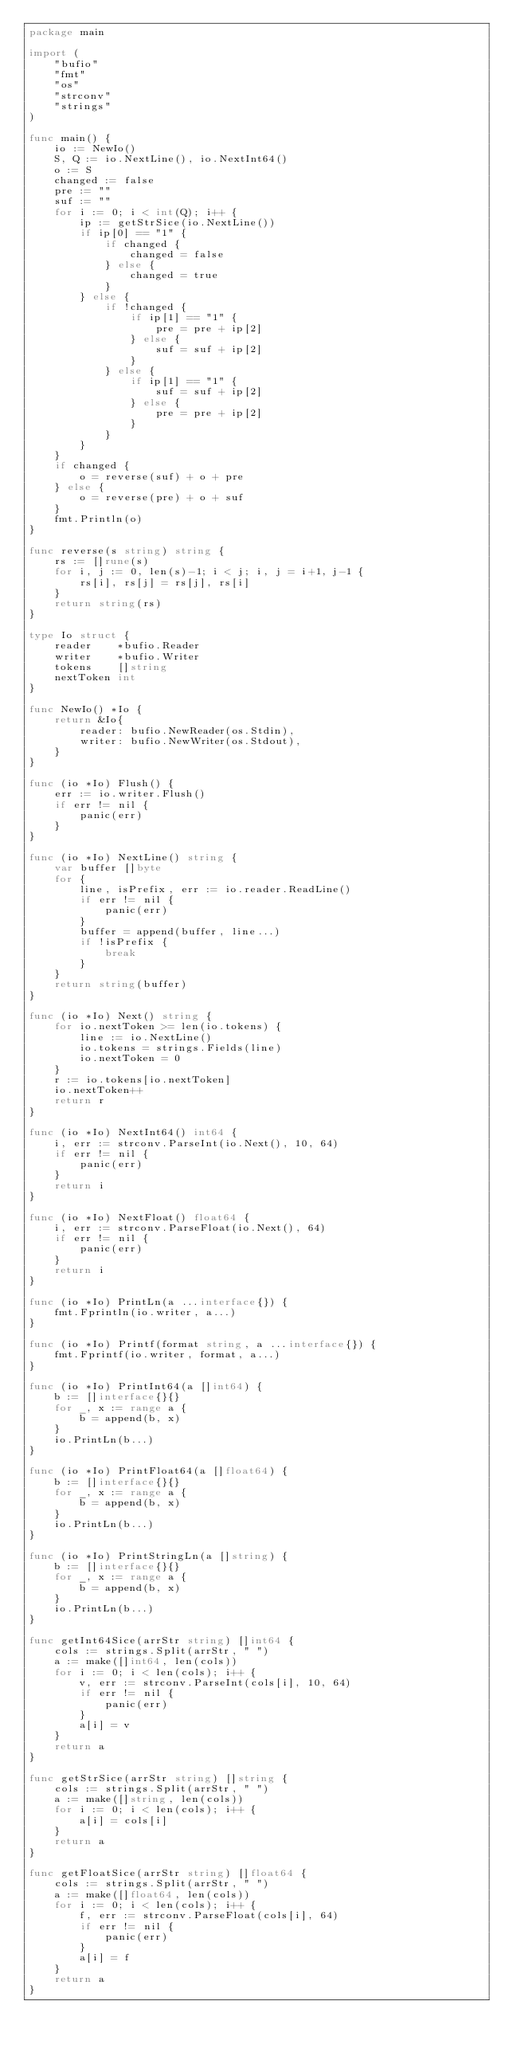Convert code to text. <code><loc_0><loc_0><loc_500><loc_500><_Go_>package main

import (
	"bufio"
	"fmt"
	"os"
	"strconv"
	"strings"
)

func main() {
	io := NewIo()
	S, Q := io.NextLine(), io.NextInt64()
	o := S
	changed := false
	pre := ""
	suf := ""
	for i := 0; i < int(Q); i++ {
		ip := getStrSice(io.NextLine())
		if ip[0] == "1" {
			if changed {
				changed = false
			} else {
				changed = true
			}
		} else {
			if !changed {
				if ip[1] == "1" {
					pre = pre + ip[2]
				} else {
					suf = suf + ip[2]
				}
			} else {
				if ip[1] == "1" {
					suf = suf + ip[2]
				} else {
					pre = pre + ip[2]
				}
			}
		}
	}
	if changed {
		o = reverse(suf) + o + pre
	} else {
		o = reverse(pre) + o + suf
	}
	fmt.Println(o)
}

func reverse(s string) string {
	rs := []rune(s)
	for i, j := 0, len(s)-1; i < j; i, j = i+1, j-1 {
		rs[i], rs[j] = rs[j], rs[i]
	}
	return string(rs)
}

type Io struct {
	reader    *bufio.Reader
	writer    *bufio.Writer
	tokens    []string
	nextToken int
}

func NewIo() *Io {
	return &Io{
		reader: bufio.NewReader(os.Stdin),
		writer: bufio.NewWriter(os.Stdout),
	}
}

func (io *Io) Flush() {
	err := io.writer.Flush()
	if err != nil {
		panic(err)
	}
}

func (io *Io) NextLine() string {
	var buffer []byte
	for {
		line, isPrefix, err := io.reader.ReadLine()
		if err != nil {
			panic(err)
		}
		buffer = append(buffer, line...)
		if !isPrefix {
			break
		}
	}
	return string(buffer)
}

func (io *Io) Next() string {
	for io.nextToken >= len(io.tokens) {
		line := io.NextLine()
		io.tokens = strings.Fields(line)
		io.nextToken = 0
	}
	r := io.tokens[io.nextToken]
	io.nextToken++
	return r
}

func (io *Io) NextInt64() int64 {
	i, err := strconv.ParseInt(io.Next(), 10, 64)
	if err != nil {
		panic(err)
	}
	return i
}

func (io *Io) NextFloat() float64 {
	i, err := strconv.ParseFloat(io.Next(), 64)
	if err != nil {
		panic(err)
	}
	return i
}

func (io *Io) PrintLn(a ...interface{}) {
	fmt.Fprintln(io.writer, a...)
}

func (io *Io) Printf(format string, a ...interface{}) {
	fmt.Fprintf(io.writer, format, a...)
}

func (io *Io) PrintInt64(a []int64) {
	b := []interface{}{}
	for _, x := range a {
		b = append(b, x)
	}
	io.PrintLn(b...)
}

func (io *Io) PrintFloat64(a []float64) {
	b := []interface{}{}
	for _, x := range a {
		b = append(b, x)
	}
	io.PrintLn(b...)
}

func (io *Io) PrintStringLn(a []string) {
	b := []interface{}{}
	for _, x := range a {
		b = append(b, x)
	}
	io.PrintLn(b...)
}

func getInt64Sice(arrStr string) []int64 {
	cols := strings.Split(arrStr, " ")
	a := make([]int64, len(cols))
	for i := 0; i < len(cols); i++ {
		v, err := strconv.ParseInt(cols[i], 10, 64)
		if err != nil {
			panic(err)
		}
		a[i] = v
	}
	return a
}

func getStrSice(arrStr string) []string {
	cols := strings.Split(arrStr, " ")
	a := make([]string, len(cols))
	for i := 0; i < len(cols); i++ {
		a[i] = cols[i]
	}
	return a
}

func getFloatSice(arrStr string) []float64 {
	cols := strings.Split(arrStr, " ")
	a := make([]float64, len(cols))
	for i := 0; i < len(cols); i++ {
		f, err := strconv.ParseFloat(cols[i], 64)
		if err != nil {
			panic(err)
		}
		a[i] = f
	}
	return a
}
</code> 